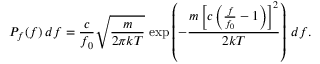Convert formula to latex. <formula><loc_0><loc_0><loc_500><loc_500>P _ { f } ( f ) \, d f = { \frac { c } { f _ { 0 } } } { \sqrt { \frac { m } { 2 \pi k T } } } \, \exp \left ( - { \frac { m \left [ c \left ( { \frac { f } { f _ { 0 } } } - 1 \right ) \right ] ^ { 2 } } { 2 k T } } \right ) \, d f .</formula> 